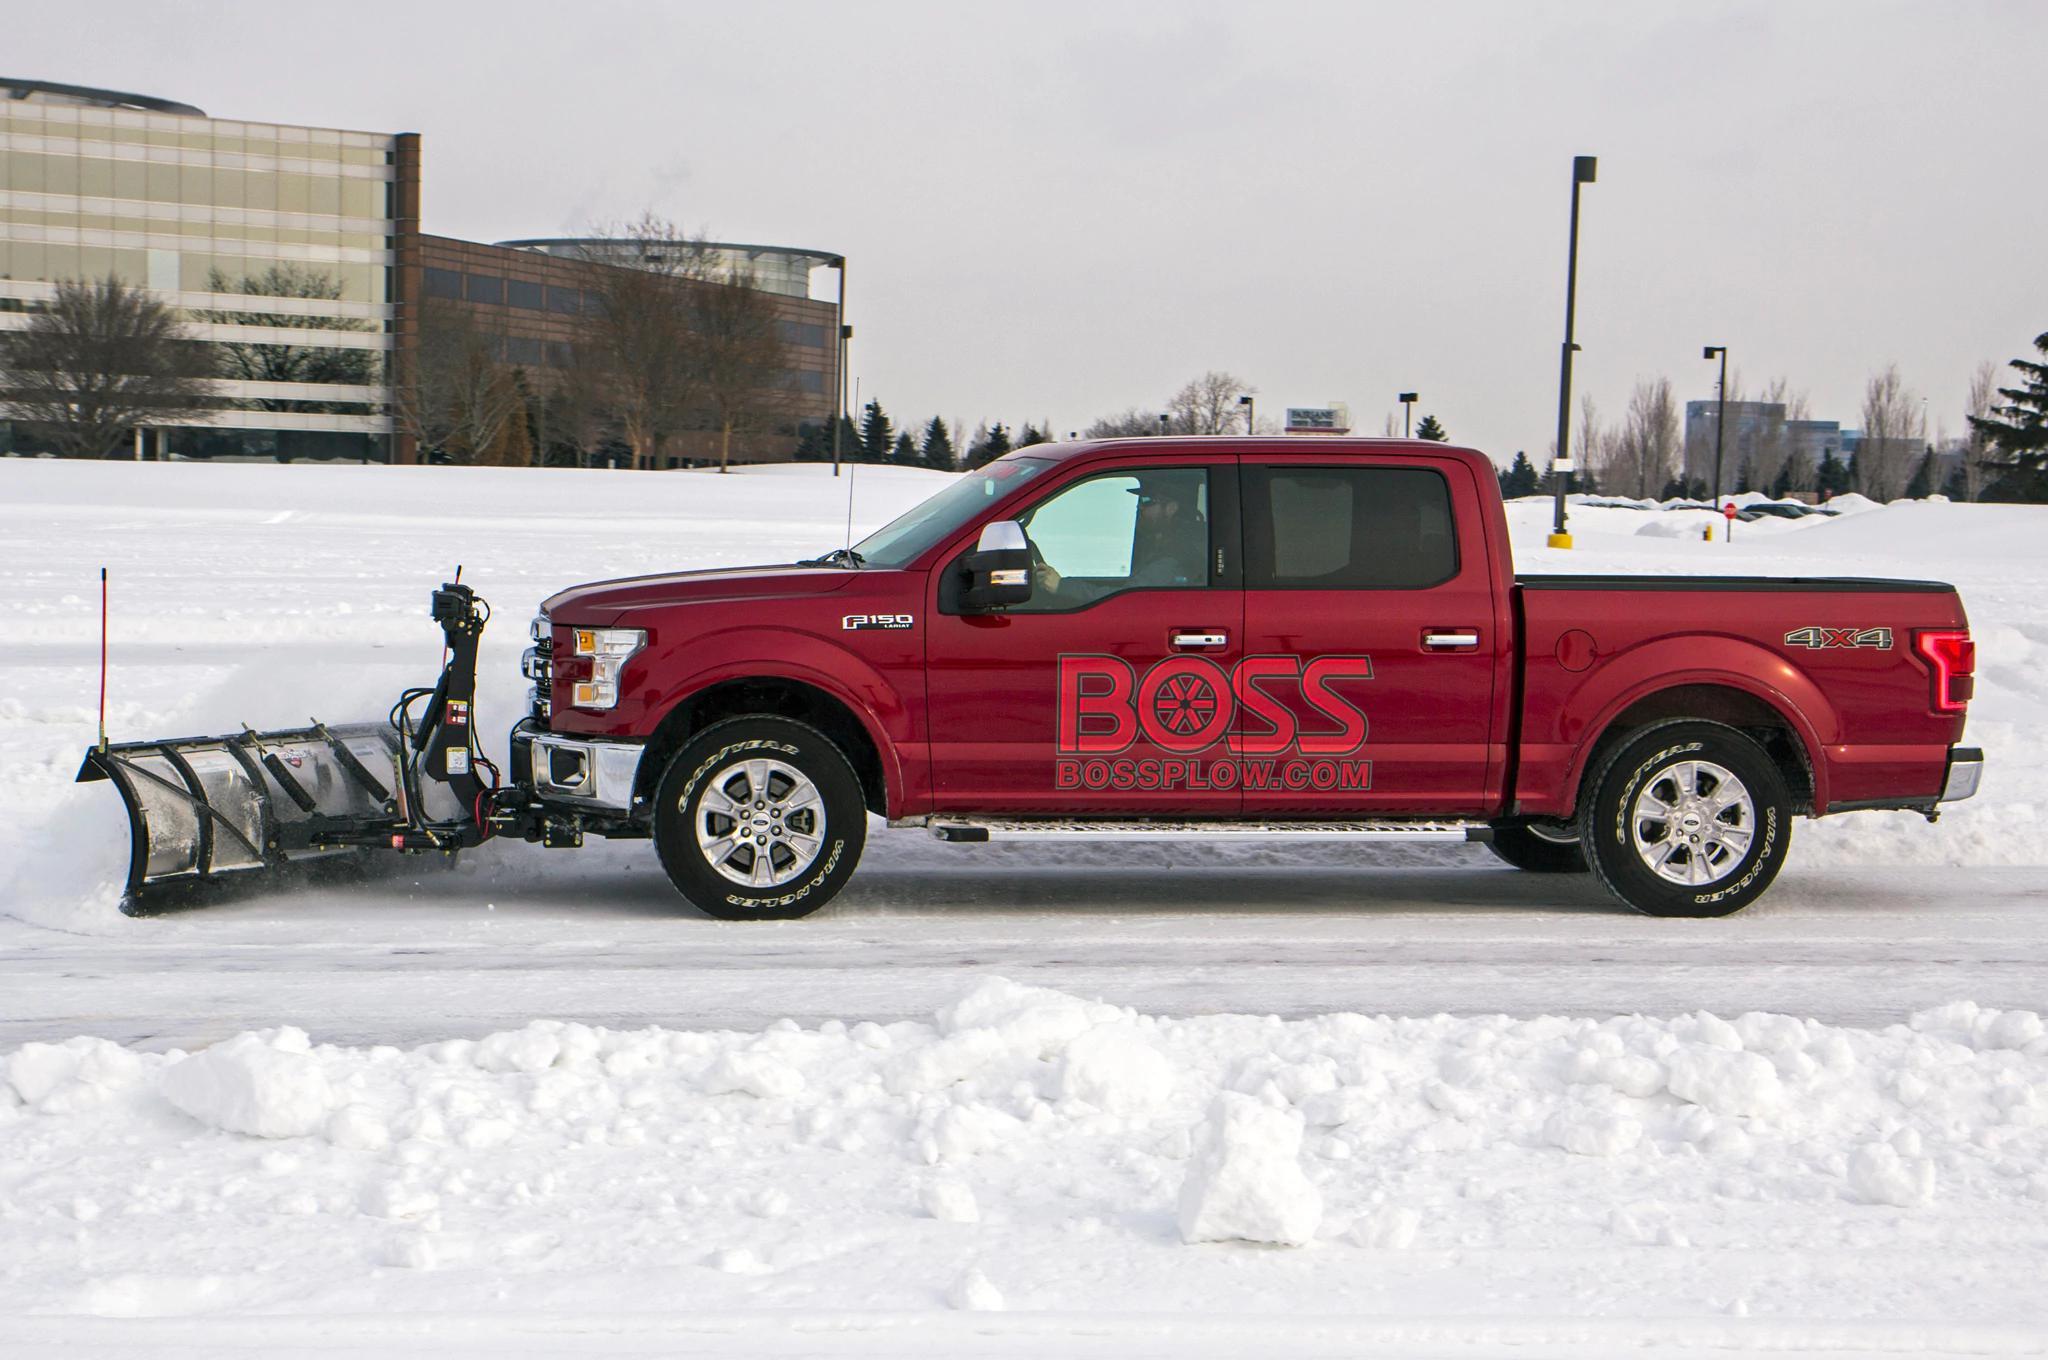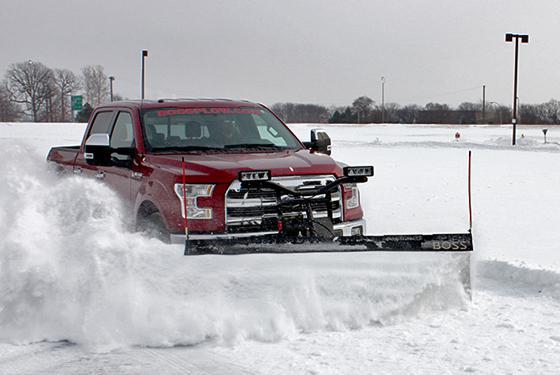The first image is the image on the left, the second image is the image on the right. For the images displayed, is the sentence "A red truck pushes a plow through the snow in each of the images." factually correct? Answer yes or no. Yes. The first image is the image on the left, the second image is the image on the right. Evaluate the accuracy of this statement regarding the images: "One image shows a non-red pickup truck pushing a large mound of snow with a plow.". Is it true? Answer yes or no. No. 